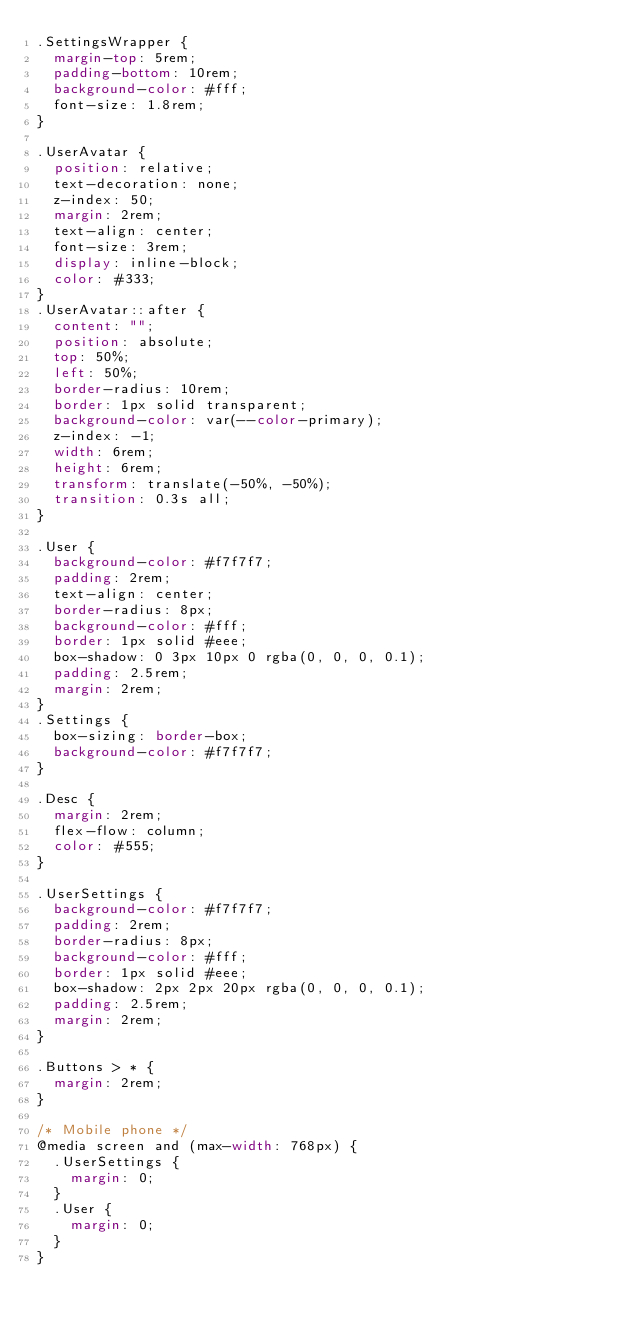Convert code to text. <code><loc_0><loc_0><loc_500><loc_500><_CSS_>.SettingsWrapper {
	margin-top: 5rem;
	padding-bottom: 10rem;
	background-color: #fff;
	font-size: 1.8rem;
}

.UserAvatar {
	position: relative;
	text-decoration: none;
	z-index: 50;
	margin: 2rem;
	text-align: center;
	font-size: 3rem;
	display: inline-block;
	color: #333;
}
.UserAvatar::after {
	content: "";
	position: absolute;
	top: 50%;
	left: 50%;
	border-radius: 10rem;
	border: 1px solid transparent;
	background-color: var(--color-primary);
	z-index: -1;
	width: 6rem;
	height: 6rem;
	transform: translate(-50%, -50%);
	transition: 0.3s all;
}

.User {
	background-color: #f7f7f7;
	padding: 2rem;
	text-align: center;
	border-radius: 8px;
	background-color: #fff;
	border: 1px solid #eee;
	box-shadow: 0 3px 10px 0 rgba(0, 0, 0, 0.1);
	padding: 2.5rem;
	margin: 2rem;
}
.Settings {
	box-sizing: border-box;
	background-color: #f7f7f7;
}

.Desc {
	margin: 2rem;
	flex-flow: column;
	color: #555;
}

.UserSettings {
	background-color: #f7f7f7;
	padding: 2rem;
	border-radius: 8px;
	background-color: #fff;
	border: 1px solid #eee;
	box-shadow: 2px 2px 20px rgba(0, 0, 0, 0.1);
	padding: 2.5rem;
	margin: 2rem;
}

.Buttons > * {
	margin: 2rem;
}

/* Mobile phone */
@media screen and (max-width: 768px) {
	.UserSettings {
		margin: 0;
	}
	.User {
		margin: 0;
	}
}
</code> 